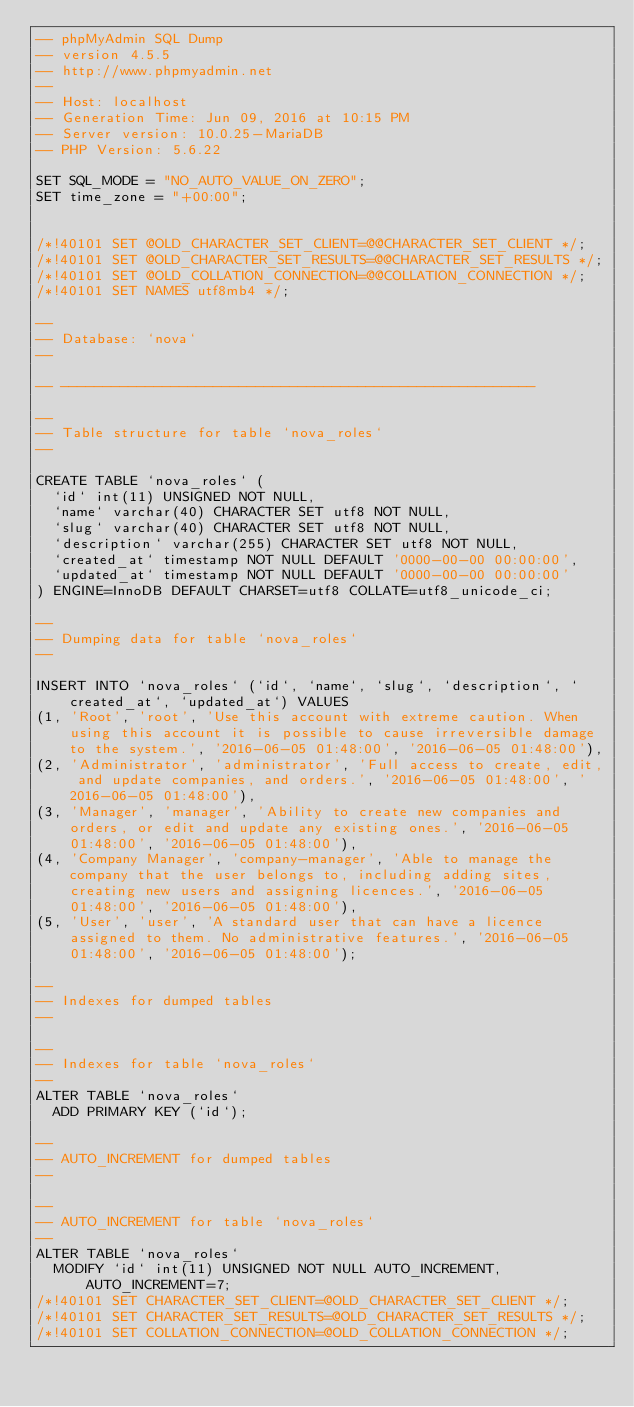<code> <loc_0><loc_0><loc_500><loc_500><_SQL_>-- phpMyAdmin SQL Dump
-- version 4.5.5
-- http://www.phpmyadmin.net
--
-- Host: localhost
-- Generation Time: Jun 09, 2016 at 10:15 PM
-- Server version: 10.0.25-MariaDB
-- PHP Version: 5.6.22

SET SQL_MODE = "NO_AUTO_VALUE_ON_ZERO";
SET time_zone = "+00:00";


/*!40101 SET @OLD_CHARACTER_SET_CLIENT=@@CHARACTER_SET_CLIENT */;
/*!40101 SET @OLD_CHARACTER_SET_RESULTS=@@CHARACTER_SET_RESULTS */;
/*!40101 SET @OLD_COLLATION_CONNECTION=@@COLLATION_CONNECTION */;
/*!40101 SET NAMES utf8mb4 */;

--
-- Database: `nova`
--

-- --------------------------------------------------------

--
-- Table structure for table `nova_roles`
--

CREATE TABLE `nova_roles` (
  `id` int(11) UNSIGNED NOT NULL,
  `name` varchar(40) CHARACTER SET utf8 NOT NULL,
  `slug` varchar(40) CHARACTER SET utf8 NOT NULL,
  `description` varchar(255) CHARACTER SET utf8 NOT NULL,
  `created_at` timestamp NOT NULL DEFAULT '0000-00-00 00:00:00',
  `updated_at` timestamp NOT NULL DEFAULT '0000-00-00 00:00:00'
) ENGINE=InnoDB DEFAULT CHARSET=utf8 COLLATE=utf8_unicode_ci;

--
-- Dumping data for table `nova_roles`
--

INSERT INTO `nova_roles` (`id`, `name`, `slug`, `description`, `created_at`, `updated_at`) VALUES
(1, 'Root', 'root', 'Use this account with extreme caution. When using this account it is possible to cause irreversible damage to the system.', '2016-06-05 01:48:00', '2016-06-05 01:48:00'),
(2, 'Administrator', 'administrator', 'Full access to create, edit, and update companies, and orders.', '2016-06-05 01:48:00', '2016-06-05 01:48:00'),
(3, 'Manager', 'manager', 'Ability to create new companies and orders, or edit and update any existing ones.', '2016-06-05 01:48:00', '2016-06-05 01:48:00'),
(4, 'Company Manager', 'company-manager', 'Able to manage the company that the user belongs to, including adding sites, creating new users and assigning licences.', '2016-06-05 01:48:00', '2016-06-05 01:48:00'),
(5, 'User', 'user', 'A standard user that can have a licence assigned to them. No administrative features.', '2016-06-05 01:48:00', '2016-06-05 01:48:00');

--
-- Indexes for dumped tables
--

--
-- Indexes for table `nova_roles`
--
ALTER TABLE `nova_roles`
  ADD PRIMARY KEY (`id`);

--
-- AUTO_INCREMENT for dumped tables
--

--
-- AUTO_INCREMENT for table `nova_roles`
--
ALTER TABLE `nova_roles`
  MODIFY `id` int(11) UNSIGNED NOT NULL AUTO_INCREMENT, AUTO_INCREMENT=7;
/*!40101 SET CHARACTER_SET_CLIENT=@OLD_CHARACTER_SET_CLIENT */;
/*!40101 SET CHARACTER_SET_RESULTS=@OLD_CHARACTER_SET_RESULTS */;
/*!40101 SET COLLATION_CONNECTION=@OLD_COLLATION_CONNECTION */;
</code> 